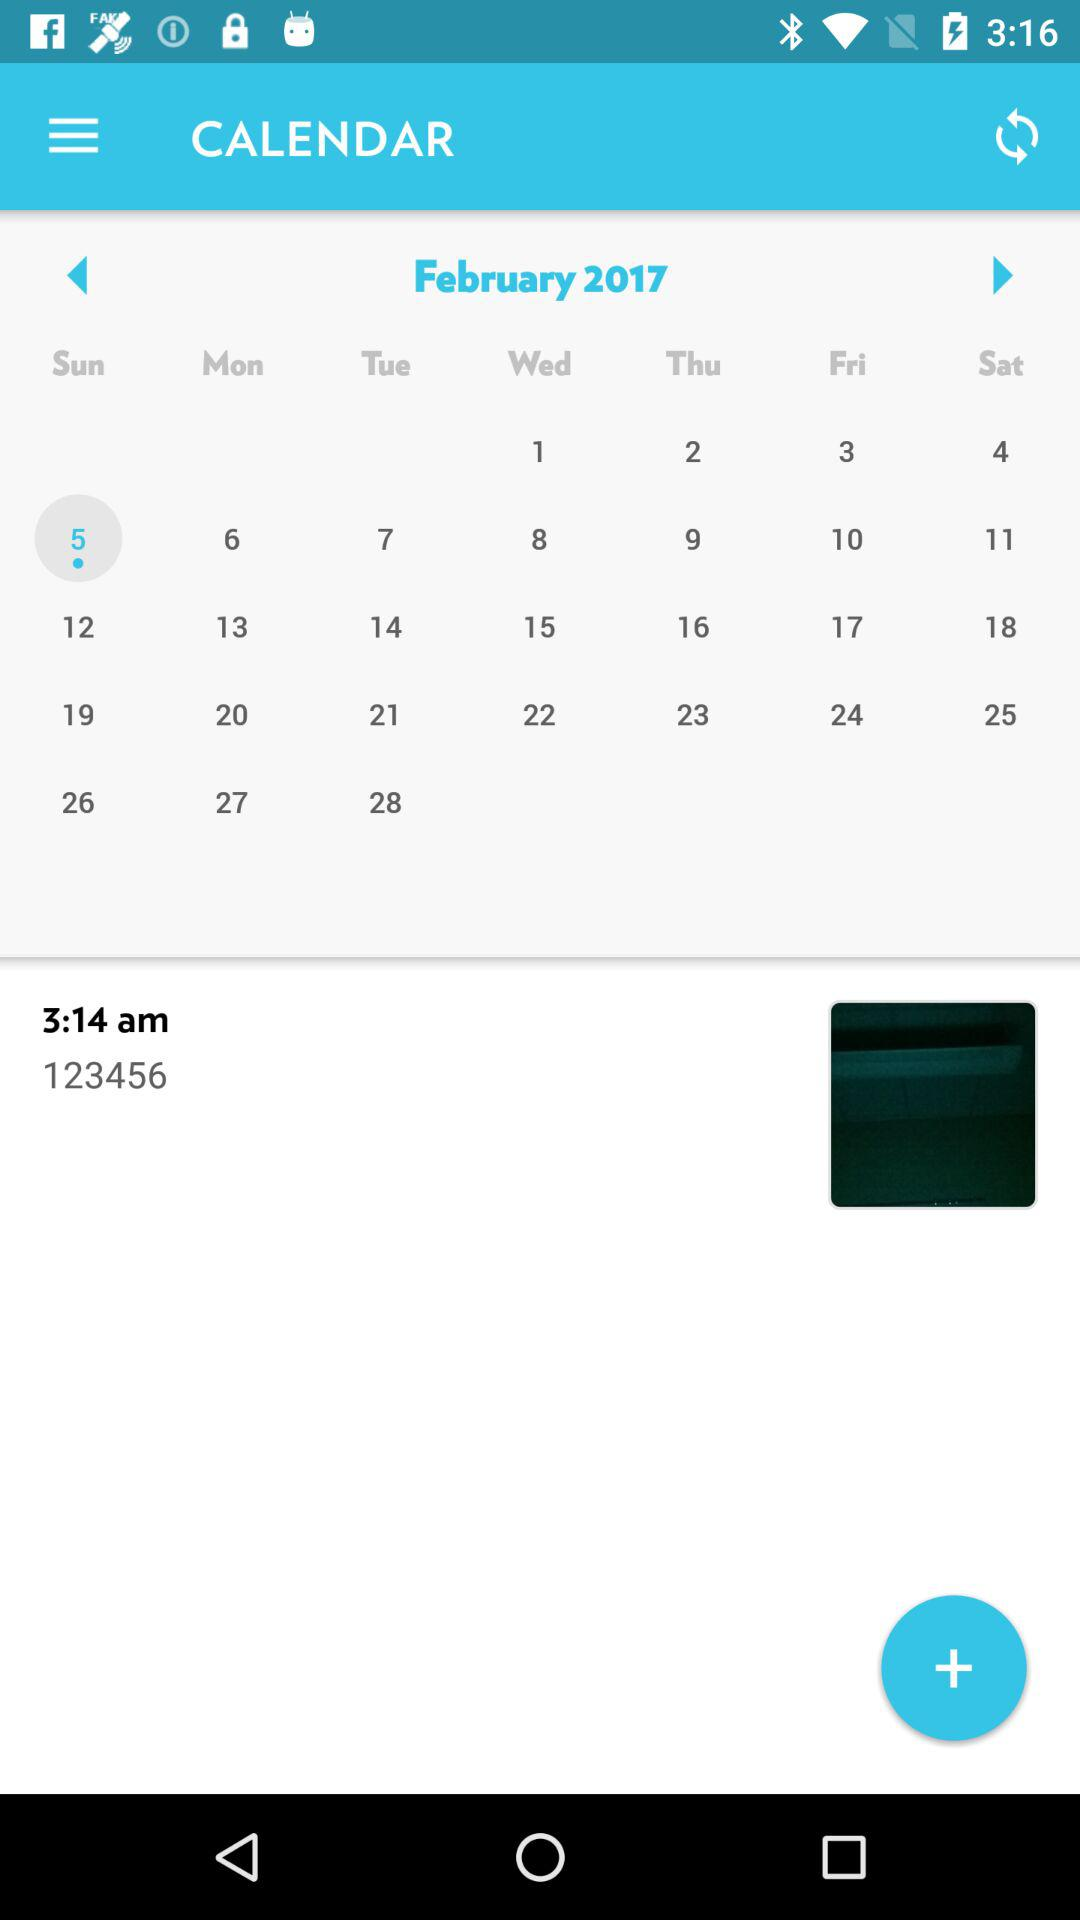What is entered in the note? The text entered in the note is "123456". 